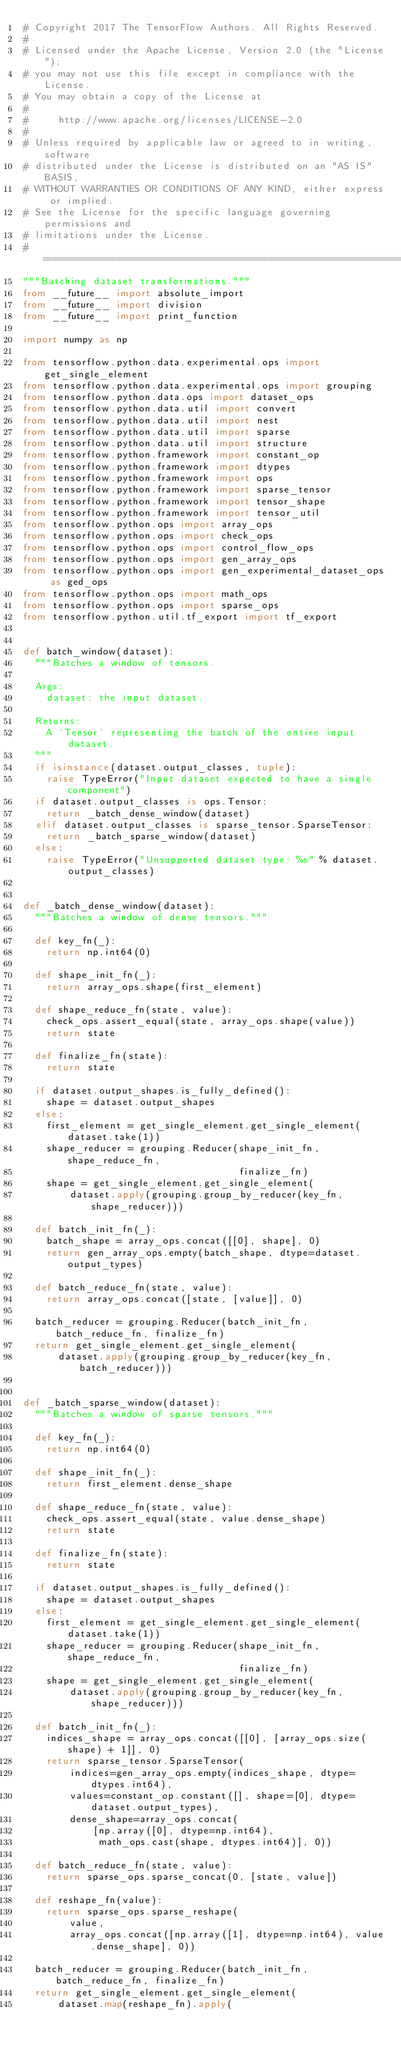<code> <loc_0><loc_0><loc_500><loc_500><_Python_># Copyright 2017 The TensorFlow Authors. All Rights Reserved.
#
# Licensed under the Apache License, Version 2.0 (the "License");
# you may not use this file except in compliance with the License.
# You may obtain a copy of the License at
#
#     http://www.apache.org/licenses/LICENSE-2.0
#
# Unless required by applicable law or agreed to in writing, software
# distributed under the License is distributed on an "AS IS" BASIS,
# WITHOUT WARRANTIES OR CONDITIONS OF ANY KIND, either express or implied.
# See the License for the specific language governing permissions and
# limitations under the License.
# ==============================================================================
"""Batching dataset transformations."""
from __future__ import absolute_import
from __future__ import division
from __future__ import print_function

import numpy as np

from tensorflow.python.data.experimental.ops import get_single_element
from tensorflow.python.data.experimental.ops import grouping
from tensorflow.python.data.ops import dataset_ops
from tensorflow.python.data.util import convert
from tensorflow.python.data.util import nest
from tensorflow.python.data.util import sparse
from tensorflow.python.data.util import structure
from tensorflow.python.framework import constant_op
from tensorflow.python.framework import dtypes
from tensorflow.python.framework import ops
from tensorflow.python.framework import sparse_tensor
from tensorflow.python.framework import tensor_shape
from tensorflow.python.framework import tensor_util
from tensorflow.python.ops import array_ops
from tensorflow.python.ops import check_ops
from tensorflow.python.ops import control_flow_ops
from tensorflow.python.ops import gen_array_ops
from tensorflow.python.ops import gen_experimental_dataset_ops as ged_ops
from tensorflow.python.ops import math_ops
from tensorflow.python.ops import sparse_ops
from tensorflow.python.util.tf_export import tf_export


def batch_window(dataset):
  """Batches a window of tensors.

  Args:
    dataset: the input dataset.

  Returns:
    A `Tensor` representing the batch of the entire input dataset.
  """
  if isinstance(dataset.output_classes, tuple):
    raise TypeError("Input dataset expected to have a single component")
  if dataset.output_classes is ops.Tensor:
    return _batch_dense_window(dataset)
  elif dataset.output_classes is sparse_tensor.SparseTensor:
    return _batch_sparse_window(dataset)
  else:
    raise TypeError("Unsupported dataset type: %s" % dataset.output_classes)


def _batch_dense_window(dataset):
  """Batches a window of dense tensors."""

  def key_fn(_):
    return np.int64(0)

  def shape_init_fn(_):
    return array_ops.shape(first_element)

  def shape_reduce_fn(state, value):
    check_ops.assert_equal(state, array_ops.shape(value))
    return state

  def finalize_fn(state):
    return state

  if dataset.output_shapes.is_fully_defined():
    shape = dataset.output_shapes
  else:
    first_element = get_single_element.get_single_element(dataset.take(1))
    shape_reducer = grouping.Reducer(shape_init_fn, shape_reduce_fn,
                                     finalize_fn)
    shape = get_single_element.get_single_element(
        dataset.apply(grouping.group_by_reducer(key_fn, shape_reducer)))

  def batch_init_fn(_):
    batch_shape = array_ops.concat([[0], shape], 0)
    return gen_array_ops.empty(batch_shape, dtype=dataset.output_types)

  def batch_reduce_fn(state, value):
    return array_ops.concat([state, [value]], 0)

  batch_reducer = grouping.Reducer(batch_init_fn, batch_reduce_fn, finalize_fn)
  return get_single_element.get_single_element(
      dataset.apply(grouping.group_by_reducer(key_fn, batch_reducer)))


def _batch_sparse_window(dataset):
  """Batches a window of sparse tensors."""

  def key_fn(_):
    return np.int64(0)

  def shape_init_fn(_):
    return first_element.dense_shape

  def shape_reduce_fn(state, value):
    check_ops.assert_equal(state, value.dense_shape)
    return state

  def finalize_fn(state):
    return state

  if dataset.output_shapes.is_fully_defined():
    shape = dataset.output_shapes
  else:
    first_element = get_single_element.get_single_element(dataset.take(1))
    shape_reducer = grouping.Reducer(shape_init_fn, shape_reduce_fn,
                                     finalize_fn)
    shape = get_single_element.get_single_element(
        dataset.apply(grouping.group_by_reducer(key_fn, shape_reducer)))

  def batch_init_fn(_):
    indices_shape = array_ops.concat([[0], [array_ops.size(shape) + 1]], 0)
    return sparse_tensor.SparseTensor(
        indices=gen_array_ops.empty(indices_shape, dtype=dtypes.int64),
        values=constant_op.constant([], shape=[0], dtype=dataset.output_types),
        dense_shape=array_ops.concat(
            [np.array([0], dtype=np.int64),
             math_ops.cast(shape, dtypes.int64)], 0))

  def batch_reduce_fn(state, value):
    return sparse_ops.sparse_concat(0, [state, value])

  def reshape_fn(value):
    return sparse_ops.sparse_reshape(
        value,
        array_ops.concat([np.array([1], dtype=np.int64), value.dense_shape], 0))

  batch_reducer = grouping.Reducer(batch_init_fn, batch_reduce_fn, finalize_fn)
  return get_single_element.get_single_element(
      dataset.map(reshape_fn).apply(</code> 